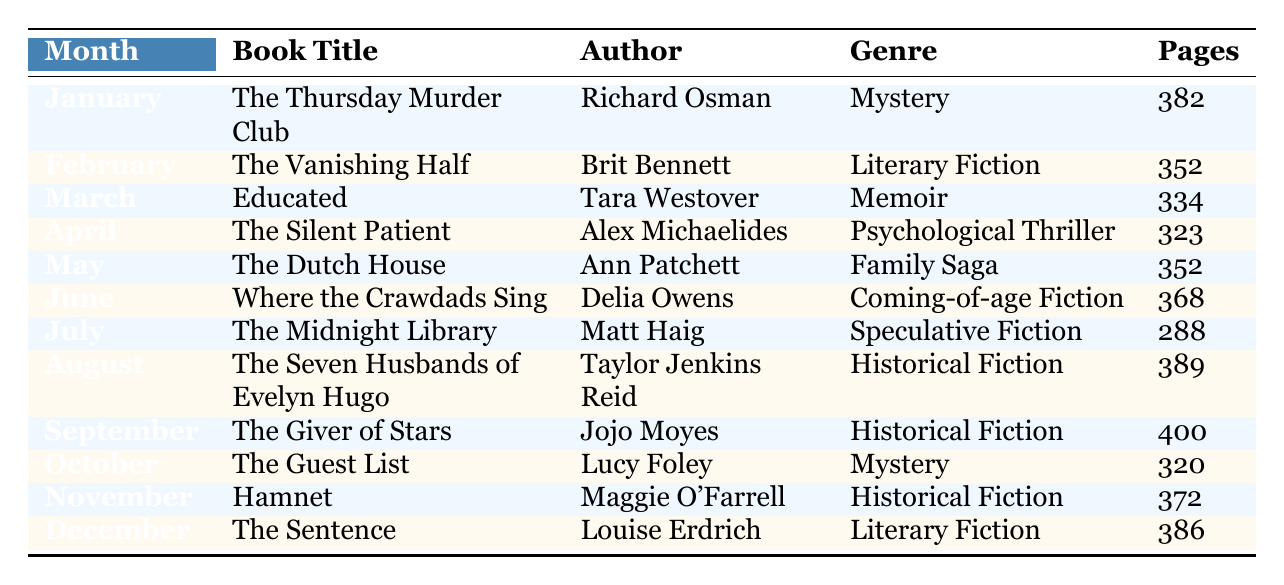What book is assigned for July? The table lists "The Midnight Library" for July.
Answer: The Midnight Library How many pages does "The Vanishing Half" have? The table shows that "The Vanishing Half" has 352 pages.
Answer: 352 pages Is "The Guest List" a Psychological Thriller? The table indicates that "The Guest List" is a Mystery, not a Psychological Thriller.
Answer: No Which author wrote the book with the most pages? By looking at the table, "The Giver of Stars" has the most pages (400), and it is written by Jojo Moyes.
Answer: Jojo Moyes What is the total number of pages for all the books read from May to October? The total pages for the books from May to October are (352 + 368 + 288 + 389 + 400 + 320) = 2117.
Answer: 2117 pages Which genre has the highest number of books in the reading list? By examining the table, there are three books classified as Historical Fiction (August, September, and November), which is more than any other genre.
Answer: Historical Fiction How many pages, on average, are there in the books from January to April? Adding the pages from January to April gives (382 + 352 + 334 + 323) = 1391. There are 4 books, so the average is 1391/4 = 347.75.
Answer: 347.75 pages Are there more Mystery books or Literary Fiction books in the list? The list contains 2 Mystery books and 3 Literary Fiction books. Thus, there are more Literary Fiction books than Mystery books.
Answer: Yes, more Literary Fiction books Which month features the book "Hamnet"? According to the table, "Hamnet" is listed for November.
Answer: November 